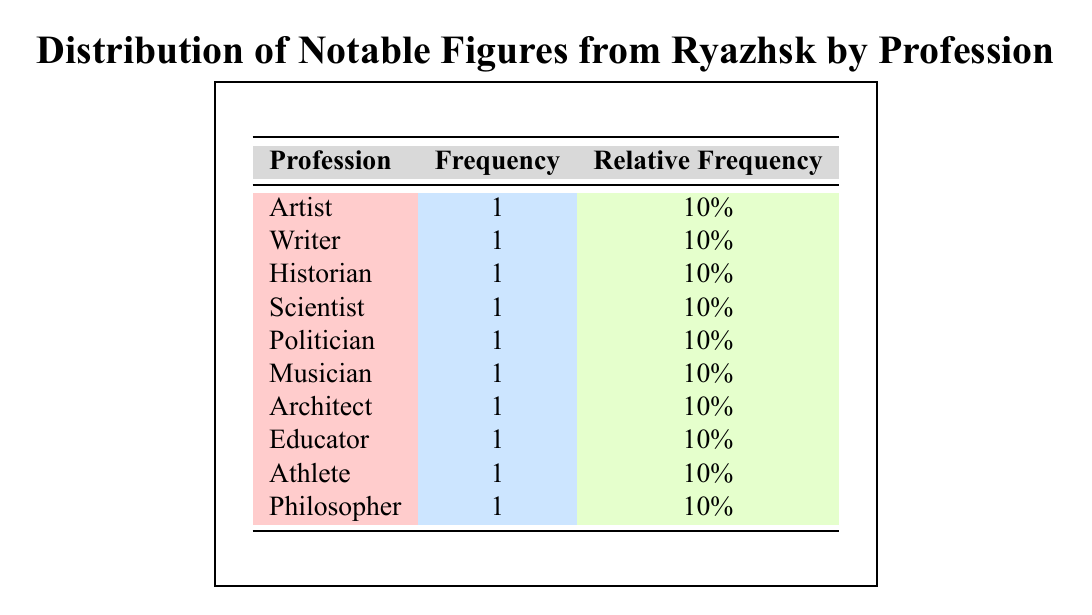What is the most common profession among notable figures from Ryazhsk? All professions listed in the table have a frequency of 1, indicating there is no most common profession.
Answer: No most common profession How many notable figures are recognized as artists? The table shows one entry under the profession "Artist," indicating there is only one notable figure who is an artist.
Answer: 1 What is the total number of notable figures from Ryazhsk listed in the table? The table lists 10 notable figures in total, one for each profession.
Answer: 10 Is there a notable figure from Ryazhsk who is both a scientist and a musician? Looking at the table, there are separate entries for "Scientist" and "Musician," and there is no individual who holds both professions.
Answer: No What percentage of the notable figures are involved in the arts or humanities (Artist, Writer, Musician, Philosopher)? There are 4 figures in the arts or humanities out of a total of 10 figures, so the calculation is (4/10) * 100 = 40%.
Answer: 40% 